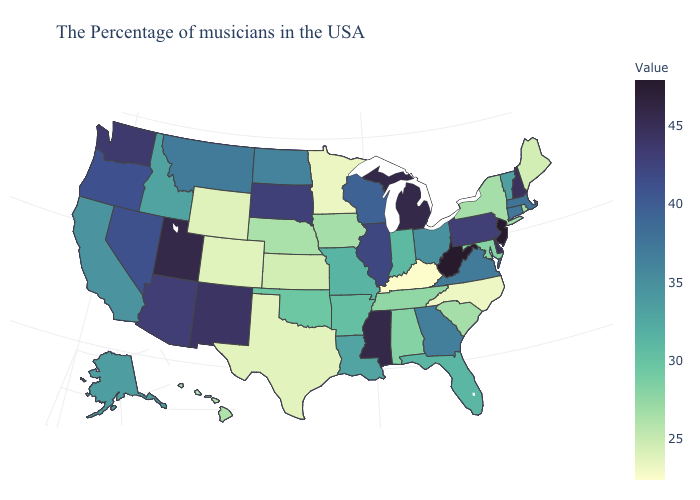Which states have the highest value in the USA?
Be succinct. West Virginia. Among the states that border Illinois , does Iowa have the highest value?
Short answer required. No. Does West Virginia have the highest value in the USA?
Be succinct. Yes. Which states have the highest value in the USA?
Give a very brief answer. West Virginia. Does Kentucky have the lowest value in the USA?
Write a very short answer. Yes. Among the states that border Pennsylvania , does New Jersey have the lowest value?
Short answer required. No. 